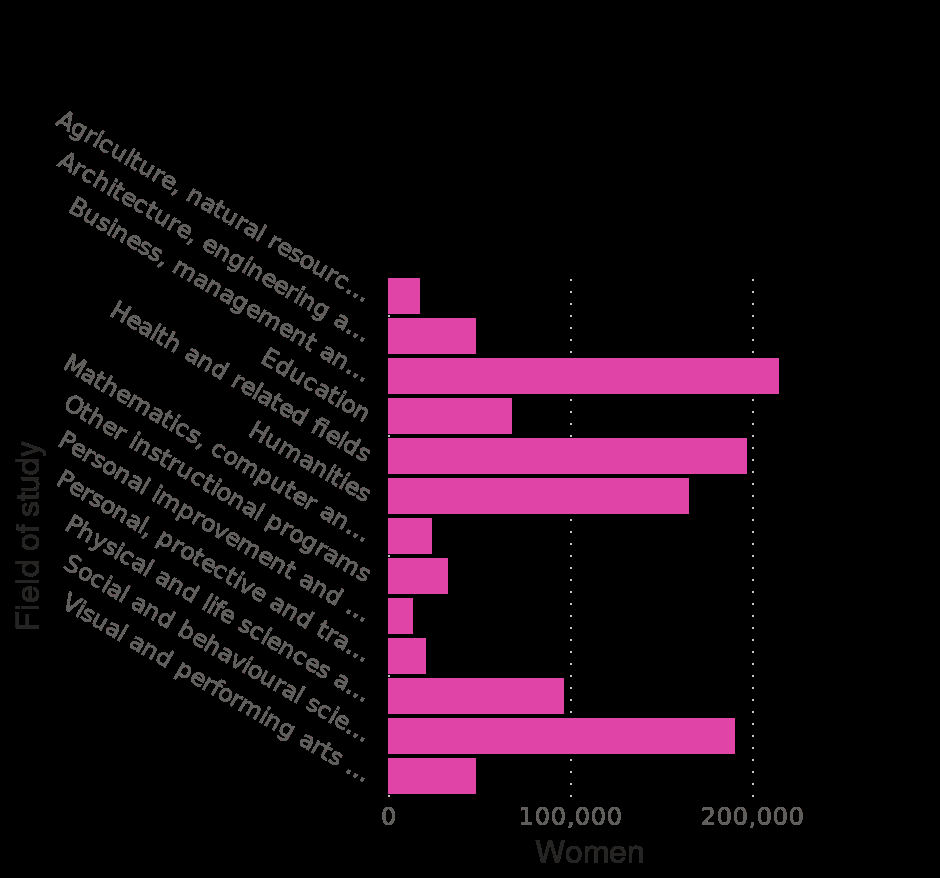<image>
What is the lowest category on the y-axis of the bar graph? The lowest category on the y-axis of the bar graph is "Agriculture, natural resources and conservation". Are these common courses popular among both males and females? Yes, these common courses are popular among both males and females. What is the title of the bar graph?  The title of the bar graph is "Number of students enrolled in postsecondary institutions in Canada in 2017/18, by gender and field of study." 